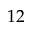Convert formula to latex. <formula><loc_0><loc_0><loc_500><loc_500>1 2</formula> 